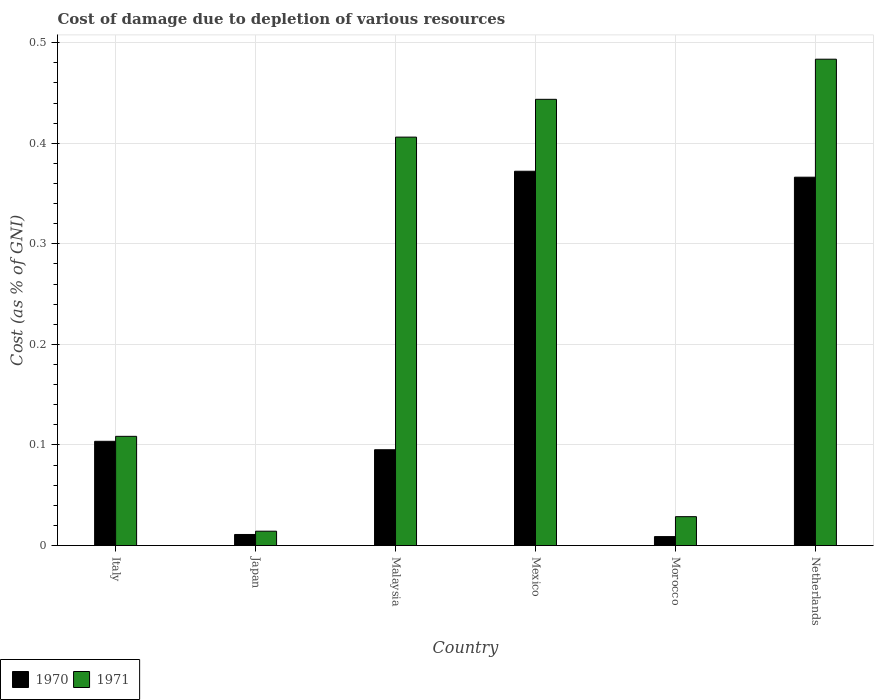Are the number of bars per tick equal to the number of legend labels?
Give a very brief answer. Yes. Are the number of bars on each tick of the X-axis equal?
Provide a short and direct response. Yes. What is the label of the 3rd group of bars from the left?
Give a very brief answer. Malaysia. In how many cases, is the number of bars for a given country not equal to the number of legend labels?
Ensure brevity in your answer.  0. What is the cost of damage caused due to the depletion of various resources in 1970 in Malaysia?
Keep it short and to the point. 0.1. Across all countries, what is the maximum cost of damage caused due to the depletion of various resources in 1971?
Your answer should be compact. 0.48. Across all countries, what is the minimum cost of damage caused due to the depletion of various resources in 1970?
Ensure brevity in your answer.  0.01. In which country was the cost of damage caused due to the depletion of various resources in 1970 minimum?
Ensure brevity in your answer.  Morocco. What is the total cost of damage caused due to the depletion of various resources in 1970 in the graph?
Your answer should be compact. 0.96. What is the difference between the cost of damage caused due to the depletion of various resources in 1971 in Italy and that in Mexico?
Ensure brevity in your answer.  -0.34. What is the difference between the cost of damage caused due to the depletion of various resources in 1971 in Morocco and the cost of damage caused due to the depletion of various resources in 1970 in Japan?
Your answer should be compact. 0.02. What is the average cost of damage caused due to the depletion of various resources in 1970 per country?
Offer a very short reply. 0.16. What is the difference between the cost of damage caused due to the depletion of various resources of/in 1970 and cost of damage caused due to the depletion of various resources of/in 1971 in Morocco?
Offer a terse response. -0.02. What is the ratio of the cost of damage caused due to the depletion of various resources in 1970 in Italy to that in Mexico?
Offer a terse response. 0.28. Is the cost of damage caused due to the depletion of various resources in 1971 in Italy less than that in Japan?
Offer a terse response. No. Is the difference between the cost of damage caused due to the depletion of various resources in 1970 in Japan and Malaysia greater than the difference between the cost of damage caused due to the depletion of various resources in 1971 in Japan and Malaysia?
Make the answer very short. Yes. What is the difference between the highest and the second highest cost of damage caused due to the depletion of various resources in 1970?
Make the answer very short. 0.27. What is the difference between the highest and the lowest cost of damage caused due to the depletion of various resources in 1971?
Offer a very short reply. 0.47. Is the sum of the cost of damage caused due to the depletion of various resources in 1970 in Japan and Netherlands greater than the maximum cost of damage caused due to the depletion of various resources in 1971 across all countries?
Provide a short and direct response. No. What does the 1st bar from the left in Netherlands represents?
Offer a terse response. 1970. What does the 2nd bar from the right in Italy represents?
Keep it short and to the point. 1970. How many countries are there in the graph?
Your response must be concise. 6. Are the values on the major ticks of Y-axis written in scientific E-notation?
Offer a terse response. No. Does the graph contain any zero values?
Your answer should be compact. No. How many legend labels are there?
Keep it short and to the point. 2. What is the title of the graph?
Provide a short and direct response. Cost of damage due to depletion of various resources. What is the label or title of the X-axis?
Offer a terse response. Country. What is the label or title of the Y-axis?
Make the answer very short. Cost (as % of GNI). What is the Cost (as % of GNI) in 1970 in Italy?
Provide a short and direct response. 0.1. What is the Cost (as % of GNI) of 1971 in Italy?
Provide a succinct answer. 0.11. What is the Cost (as % of GNI) in 1970 in Japan?
Keep it short and to the point. 0.01. What is the Cost (as % of GNI) of 1971 in Japan?
Your response must be concise. 0.01. What is the Cost (as % of GNI) of 1970 in Malaysia?
Offer a very short reply. 0.1. What is the Cost (as % of GNI) in 1971 in Malaysia?
Keep it short and to the point. 0.41. What is the Cost (as % of GNI) of 1970 in Mexico?
Offer a very short reply. 0.37. What is the Cost (as % of GNI) in 1971 in Mexico?
Your answer should be very brief. 0.44. What is the Cost (as % of GNI) in 1970 in Morocco?
Make the answer very short. 0.01. What is the Cost (as % of GNI) in 1971 in Morocco?
Your answer should be very brief. 0.03. What is the Cost (as % of GNI) in 1970 in Netherlands?
Give a very brief answer. 0.37. What is the Cost (as % of GNI) of 1971 in Netherlands?
Make the answer very short. 0.48. Across all countries, what is the maximum Cost (as % of GNI) of 1970?
Offer a terse response. 0.37. Across all countries, what is the maximum Cost (as % of GNI) of 1971?
Provide a short and direct response. 0.48. Across all countries, what is the minimum Cost (as % of GNI) in 1970?
Offer a terse response. 0.01. Across all countries, what is the minimum Cost (as % of GNI) in 1971?
Keep it short and to the point. 0.01. What is the total Cost (as % of GNI) in 1970 in the graph?
Your answer should be very brief. 0.96. What is the total Cost (as % of GNI) of 1971 in the graph?
Make the answer very short. 1.49. What is the difference between the Cost (as % of GNI) of 1970 in Italy and that in Japan?
Keep it short and to the point. 0.09. What is the difference between the Cost (as % of GNI) of 1971 in Italy and that in Japan?
Give a very brief answer. 0.09. What is the difference between the Cost (as % of GNI) of 1970 in Italy and that in Malaysia?
Provide a succinct answer. 0.01. What is the difference between the Cost (as % of GNI) in 1971 in Italy and that in Malaysia?
Your answer should be compact. -0.3. What is the difference between the Cost (as % of GNI) of 1970 in Italy and that in Mexico?
Offer a terse response. -0.27. What is the difference between the Cost (as % of GNI) of 1971 in Italy and that in Mexico?
Make the answer very short. -0.34. What is the difference between the Cost (as % of GNI) in 1970 in Italy and that in Morocco?
Your answer should be compact. 0.09. What is the difference between the Cost (as % of GNI) of 1971 in Italy and that in Morocco?
Provide a succinct answer. 0.08. What is the difference between the Cost (as % of GNI) of 1970 in Italy and that in Netherlands?
Your answer should be compact. -0.26. What is the difference between the Cost (as % of GNI) in 1971 in Italy and that in Netherlands?
Provide a succinct answer. -0.38. What is the difference between the Cost (as % of GNI) in 1970 in Japan and that in Malaysia?
Offer a very short reply. -0.08. What is the difference between the Cost (as % of GNI) of 1971 in Japan and that in Malaysia?
Your answer should be compact. -0.39. What is the difference between the Cost (as % of GNI) in 1970 in Japan and that in Mexico?
Offer a terse response. -0.36. What is the difference between the Cost (as % of GNI) in 1971 in Japan and that in Mexico?
Offer a very short reply. -0.43. What is the difference between the Cost (as % of GNI) in 1970 in Japan and that in Morocco?
Offer a very short reply. 0. What is the difference between the Cost (as % of GNI) of 1971 in Japan and that in Morocco?
Offer a terse response. -0.01. What is the difference between the Cost (as % of GNI) of 1970 in Japan and that in Netherlands?
Make the answer very short. -0.36. What is the difference between the Cost (as % of GNI) in 1971 in Japan and that in Netherlands?
Provide a short and direct response. -0.47. What is the difference between the Cost (as % of GNI) in 1970 in Malaysia and that in Mexico?
Your answer should be compact. -0.28. What is the difference between the Cost (as % of GNI) of 1971 in Malaysia and that in Mexico?
Your answer should be very brief. -0.04. What is the difference between the Cost (as % of GNI) in 1970 in Malaysia and that in Morocco?
Offer a terse response. 0.09. What is the difference between the Cost (as % of GNI) in 1971 in Malaysia and that in Morocco?
Your answer should be compact. 0.38. What is the difference between the Cost (as % of GNI) in 1970 in Malaysia and that in Netherlands?
Offer a terse response. -0.27. What is the difference between the Cost (as % of GNI) of 1971 in Malaysia and that in Netherlands?
Make the answer very short. -0.08. What is the difference between the Cost (as % of GNI) in 1970 in Mexico and that in Morocco?
Keep it short and to the point. 0.36. What is the difference between the Cost (as % of GNI) in 1971 in Mexico and that in Morocco?
Give a very brief answer. 0.41. What is the difference between the Cost (as % of GNI) of 1970 in Mexico and that in Netherlands?
Your answer should be very brief. 0.01. What is the difference between the Cost (as % of GNI) of 1971 in Mexico and that in Netherlands?
Make the answer very short. -0.04. What is the difference between the Cost (as % of GNI) in 1970 in Morocco and that in Netherlands?
Your answer should be very brief. -0.36. What is the difference between the Cost (as % of GNI) in 1971 in Morocco and that in Netherlands?
Provide a succinct answer. -0.45. What is the difference between the Cost (as % of GNI) of 1970 in Italy and the Cost (as % of GNI) of 1971 in Japan?
Ensure brevity in your answer.  0.09. What is the difference between the Cost (as % of GNI) of 1970 in Italy and the Cost (as % of GNI) of 1971 in Malaysia?
Offer a very short reply. -0.3. What is the difference between the Cost (as % of GNI) of 1970 in Italy and the Cost (as % of GNI) of 1971 in Mexico?
Offer a terse response. -0.34. What is the difference between the Cost (as % of GNI) in 1970 in Italy and the Cost (as % of GNI) in 1971 in Morocco?
Provide a succinct answer. 0.07. What is the difference between the Cost (as % of GNI) in 1970 in Italy and the Cost (as % of GNI) in 1971 in Netherlands?
Provide a succinct answer. -0.38. What is the difference between the Cost (as % of GNI) in 1970 in Japan and the Cost (as % of GNI) in 1971 in Malaysia?
Offer a very short reply. -0.4. What is the difference between the Cost (as % of GNI) in 1970 in Japan and the Cost (as % of GNI) in 1971 in Mexico?
Your answer should be compact. -0.43. What is the difference between the Cost (as % of GNI) of 1970 in Japan and the Cost (as % of GNI) of 1971 in Morocco?
Keep it short and to the point. -0.02. What is the difference between the Cost (as % of GNI) of 1970 in Japan and the Cost (as % of GNI) of 1971 in Netherlands?
Make the answer very short. -0.47. What is the difference between the Cost (as % of GNI) of 1970 in Malaysia and the Cost (as % of GNI) of 1971 in Mexico?
Your response must be concise. -0.35. What is the difference between the Cost (as % of GNI) in 1970 in Malaysia and the Cost (as % of GNI) in 1971 in Morocco?
Provide a succinct answer. 0.07. What is the difference between the Cost (as % of GNI) of 1970 in Malaysia and the Cost (as % of GNI) of 1971 in Netherlands?
Provide a succinct answer. -0.39. What is the difference between the Cost (as % of GNI) in 1970 in Mexico and the Cost (as % of GNI) in 1971 in Morocco?
Offer a terse response. 0.34. What is the difference between the Cost (as % of GNI) of 1970 in Mexico and the Cost (as % of GNI) of 1971 in Netherlands?
Ensure brevity in your answer.  -0.11. What is the difference between the Cost (as % of GNI) of 1970 in Morocco and the Cost (as % of GNI) of 1971 in Netherlands?
Ensure brevity in your answer.  -0.47. What is the average Cost (as % of GNI) of 1970 per country?
Provide a succinct answer. 0.16. What is the average Cost (as % of GNI) of 1971 per country?
Your answer should be compact. 0.25. What is the difference between the Cost (as % of GNI) in 1970 and Cost (as % of GNI) in 1971 in Italy?
Make the answer very short. -0. What is the difference between the Cost (as % of GNI) in 1970 and Cost (as % of GNI) in 1971 in Japan?
Offer a terse response. -0. What is the difference between the Cost (as % of GNI) in 1970 and Cost (as % of GNI) in 1971 in Malaysia?
Provide a short and direct response. -0.31. What is the difference between the Cost (as % of GNI) of 1970 and Cost (as % of GNI) of 1971 in Mexico?
Offer a terse response. -0.07. What is the difference between the Cost (as % of GNI) in 1970 and Cost (as % of GNI) in 1971 in Morocco?
Your answer should be compact. -0.02. What is the difference between the Cost (as % of GNI) of 1970 and Cost (as % of GNI) of 1971 in Netherlands?
Offer a terse response. -0.12. What is the ratio of the Cost (as % of GNI) of 1970 in Italy to that in Japan?
Make the answer very short. 9.41. What is the ratio of the Cost (as % of GNI) of 1971 in Italy to that in Japan?
Give a very brief answer. 7.6. What is the ratio of the Cost (as % of GNI) of 1970 in Italy to that in Malaysia?
Offer a terse response. 1.09. What is the ratio of the Cost (as % of GNI) of 1971 in Italy to that in Malaysia?
Offer a terse response. 0.27. What is the ratio of the Cost (as % of GNI) in 1970 in Italy to that in Mexico?
Offer a very short reply. 0.28. What is the ratio of the Cost (as % of GNI) of 1971 in Italy to that in Mexico?
Offer a terse response. 0.24. What is the ratio of the Cost (as % of GNI) in 1970 in Italy to that in Morocco?
Your answer should be compact. 11.64. What is the ratio of the Cost (as % of GNI) in 1971 in Italy to that in Morocco?
Your answer should be compact. 3.78. What is the ratio of the Cost (as % of GNI) in 1970 in Italy to that in Netherlands?
Offer a very short reply. 0.28. What is the ratio of the Cost (as % of GNI) in 1971 in Italy to that in Netherlands?
Keep it short and to the point. 0.22. What is the ratio of the Cost (as % of GNI) of 1970 in Japan to that in Malaysia?
Keep it short and to the point. 0.12. What is the ratio of the Cost (as % of GNI) of 1971 in Japan to that in Malaysia?
Your answer should be compact. 0.04. What is the ratio of the Cost (as % of GNI) of 1970 in Japan to that in Mexico?
Provide a succinct answer. 0.03. What is the ratio of the Cost (as % of GNI) of 1971 in Japan to that in Mexico?
Your response must be concise. 0.03. What is the ratio of the Cost (as % of GNI) in 1970 in Japan to that in Morocco?
Provide a succinct answer. 1.24. What is the ratio of the Cost (as % of GNI) of 1971 in Japan to that in Morocco?
Ensure brevity in your answer.  0.5. What is the ratio of the Cost (as % of GNI) in 1970 in Japan to that in Netherlands?
Offer a very short reply. 0.03. What is the ratio of the Cost (as % of GNI) of 1971 in Japan to that in Netherlands?
Your answer should be very brief. 0.03. What is the ratio of the Cost (as % of GNI) of 1970 in Malaysia to that in Mexico?
Ensure brevity in your answer.  0.26. What is the ratio of the Cost (as % of GNI) in 1971 in Malaysia to that in Mexico?
Your answer should be very brief. 0.92. What is the ratio of the Cost (as % of GNI) in 1970 in Malaysia to that in Morocco?
Ensure brevity in your answer.  10.69. What is the ratio of the Cost (as % of GNI) in 1971 in Malaysia to that in Morocco?
Provide a succinct answer. 14.13. What is the ratio of the Cost (as % of GNI) in 1970 in Malaysia to that in Netherlands?
Make the answer very short. 0.26. What is the ratio of the Cost (as % of GNI) of 1971 in Malaysia to that in Netherlands?
Make the answer very short. 0.84. What is the ratio of the Cost (as % of GNI) of 1970 in Mexico to that in Morocco?
Ensure brevity in your answer.  41.78. What is the ratio of the Cost (as % of GNI) of 1971 in Mexico to that in Morocco?
Give a very brief answer. 15.44. What is the ratio of the Cost (as % of GNI) of 1970 in Mexico to that in Netherlands?
Keep it short and to the point. 1.02. What is the ratio of the Cost (as % of GNI) of 1971 in Mexico to that in Netherlands?
Keep it short and to the point. 0.92. What is the ratio of the Cost (as % of GNI) in 1970 in Morocco to that in Netherlands?
Ensure brevity in your answer.  0.02. What is the ratio of the Cost (as % of GNI) of 1971 in Morocco to that in Netherlands?
Keep it short and to the point. 0.06. What is the difference between the highest and the second highest Cost (as % of GNI) in 1970?
Provide a short and direct response. 0.01. What is the difference between the highest and the second highest Cost (as % of GNI) of 1971?
Your response must be concise. 0.04. What is the difference between the highest and the lowest Cost (as % of GNI) of 1970?
Your answer should be very brief. 0.36. What is the difference between the highest and the lowest Cost (as % of GNI) in 1971?
Your response must be concise. 0.47. 